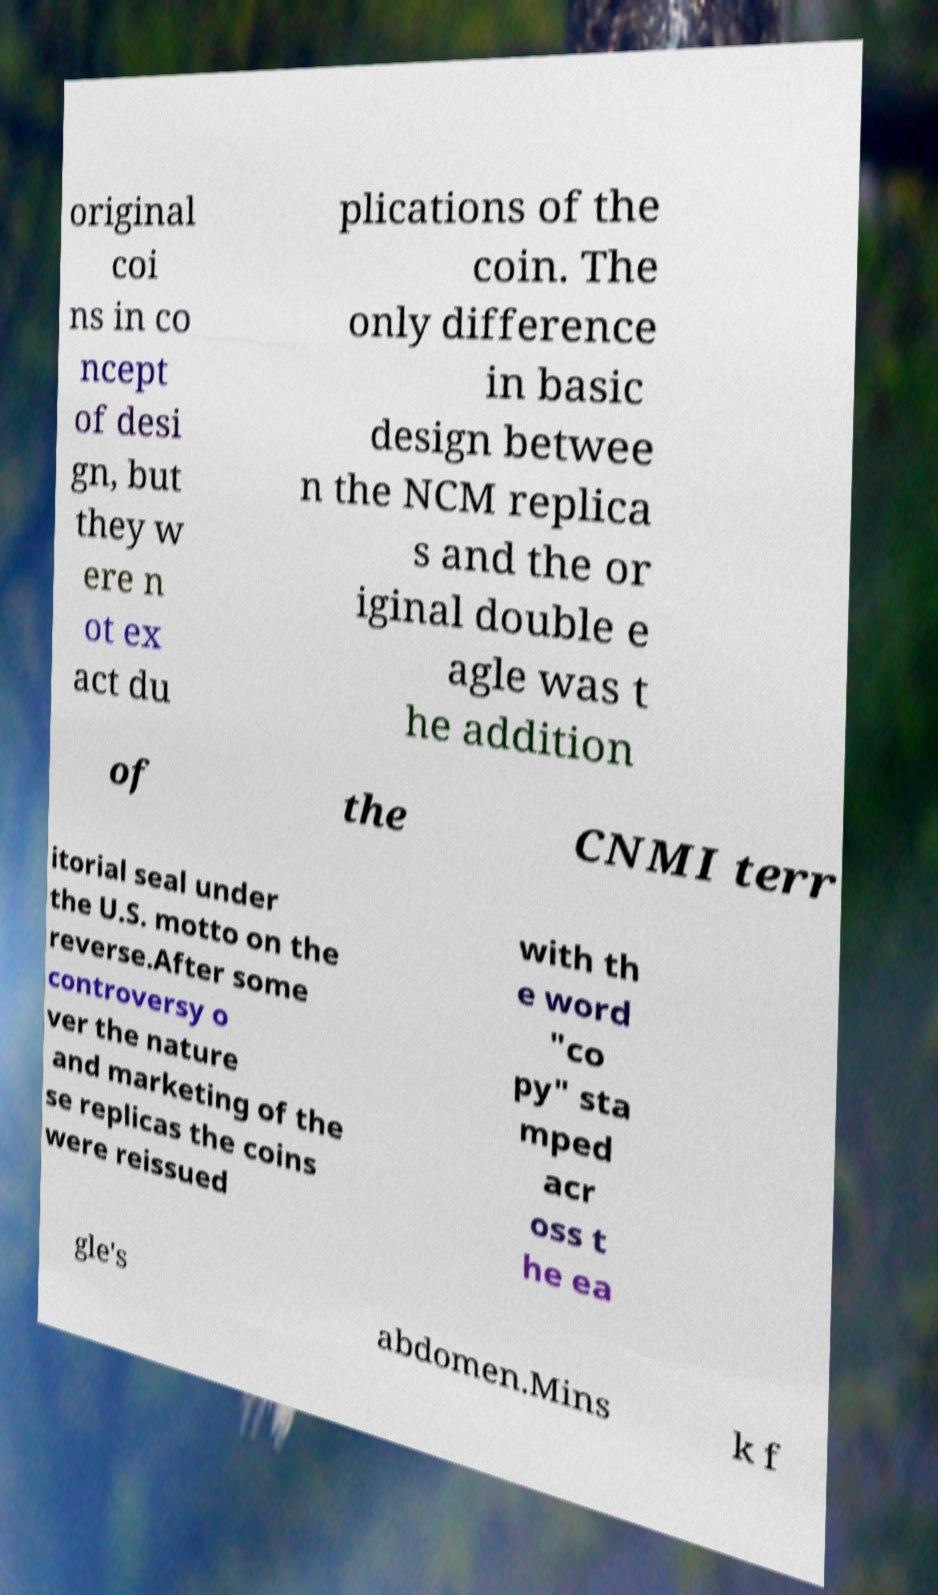Please read and relay the text visible in this image. What does it say? original coi ns in co ncept of desi gn, but they w ere n ot ex act du plications of the coin. The only difference in basic design betwee n the NCM replica s and the or iginal double e agle was t he addition of the CNMI terr itorial seal under the U.S. motto on the reverse.After some controversy o ver the nature and marketing of the se replicas the coins were reissued with th e word "co py" sta mped acr oss t he ea gle's abdomen.Mins k f 